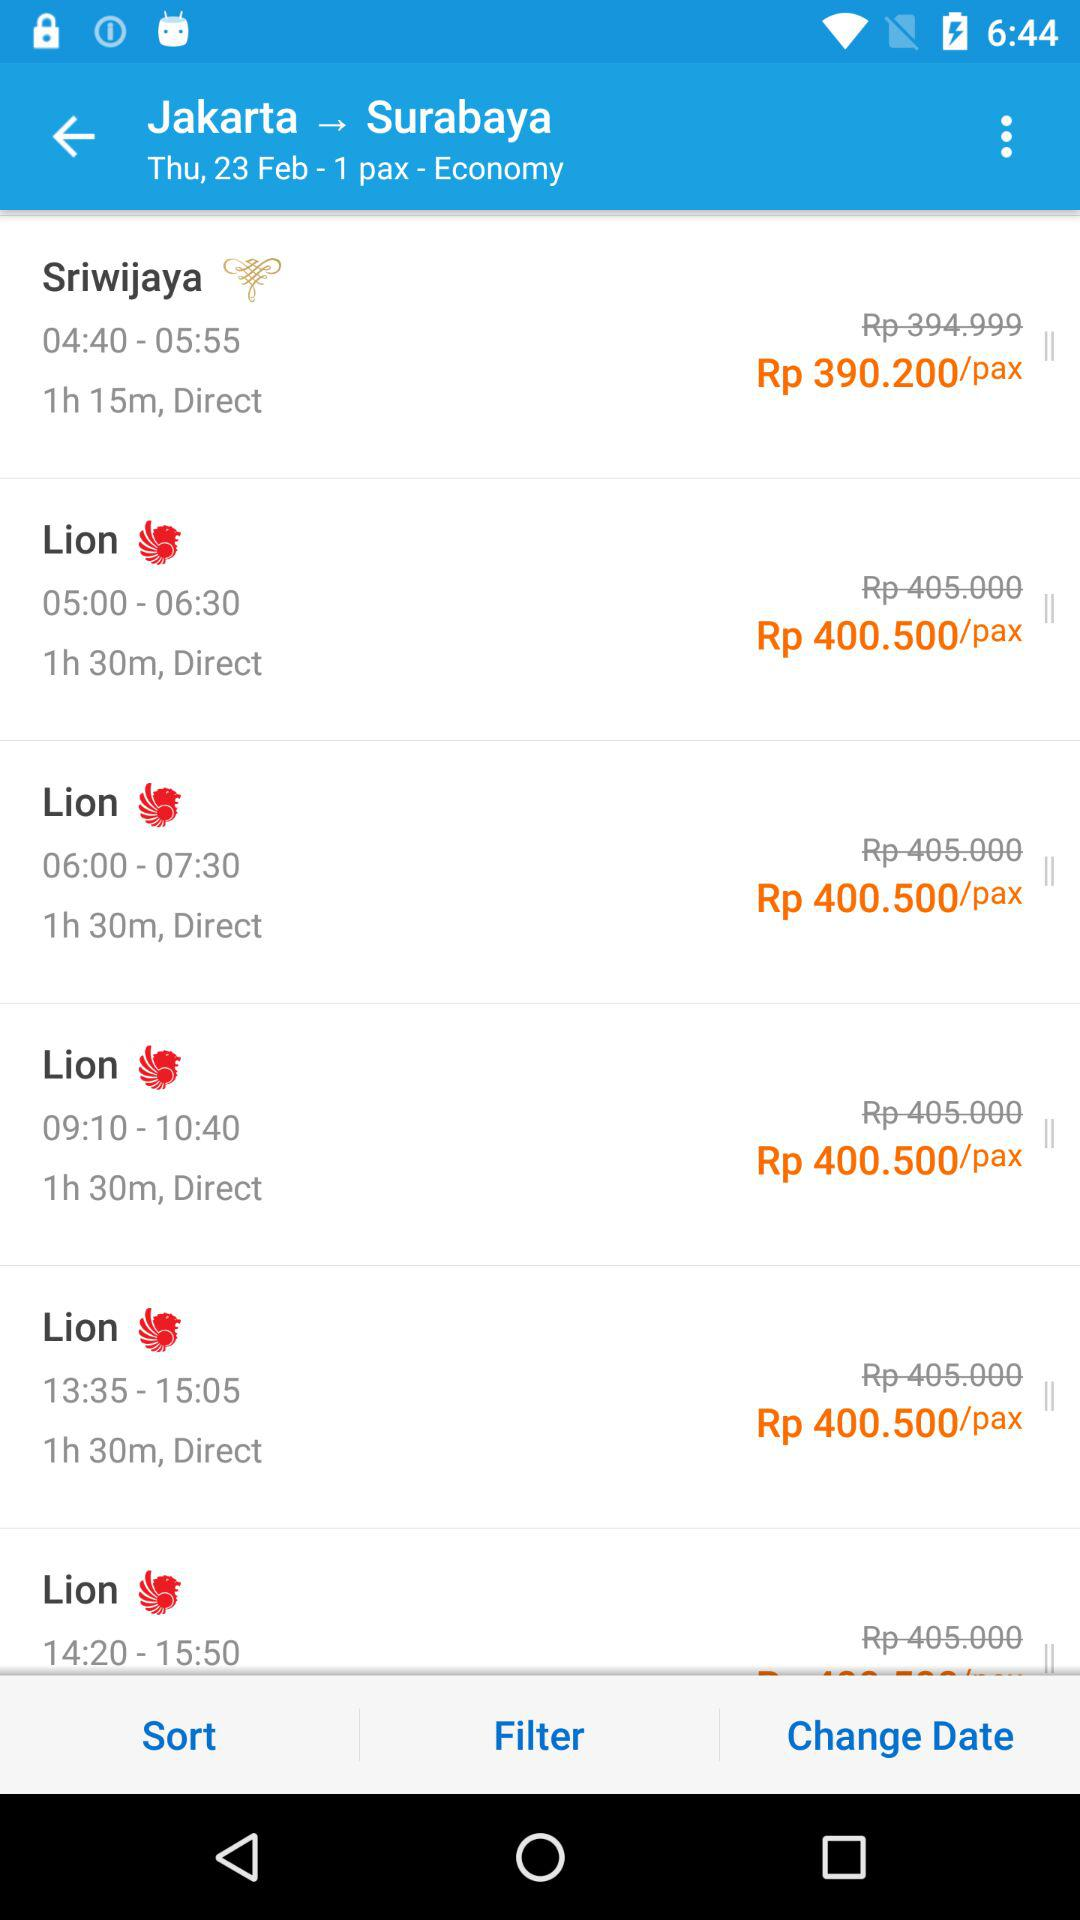How long does Sriwijaya take to reach the destination? Sriwijaya takes 1 hour 15 minutes to reach the destination. 